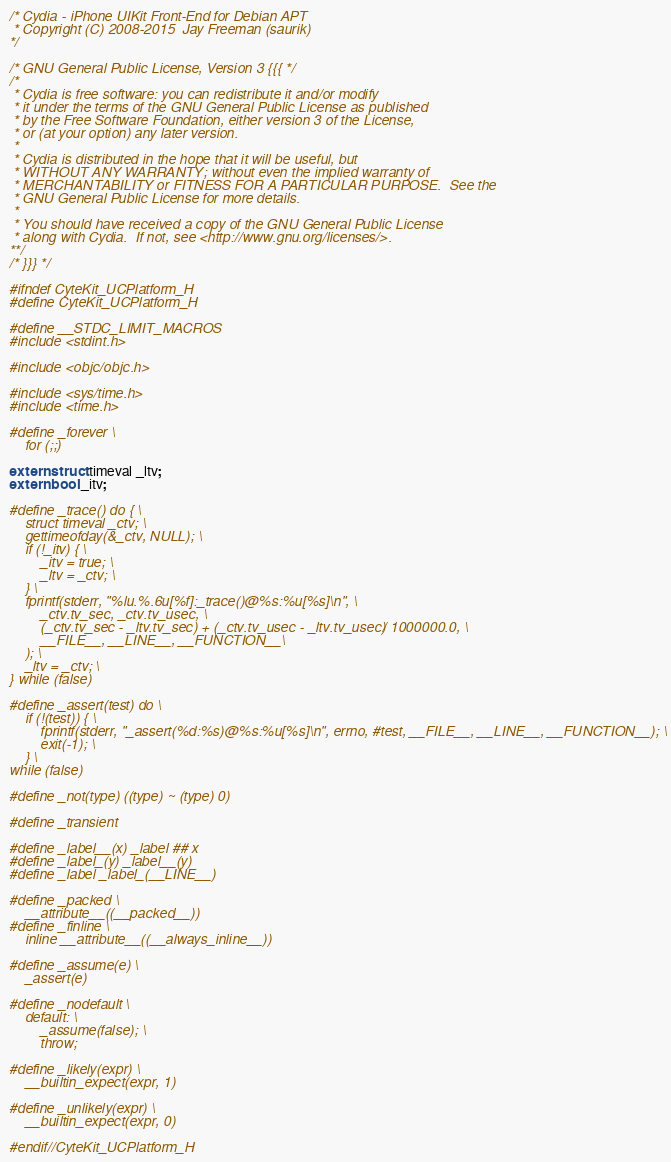<code> <loc_0><loc_0><loc_500><loc_500><_C_>/* Cydia - iPhone UIKit Front-End for Debian APT
 * Copyright (C) 2008-2015  Jay Freeman (saurik)
*/

/* GNU General Public License, Version 3 {{{ */
/*
 * Cydia is free software: you can redistribute it and/or modify
 * it under the terms of the GNU General Public License as published
 * by the Free Software Foundation, either version 3 of the License,
 * or (at your option) any later version.
 *
 * Cydia is distributed in the hope that it will be useful, but
 * WITHOUT ANY WARRANTY; without even the implied warranty of
 * MERCHANTABILITY or FITNESS FOR A PARTICULAR PURPOSE.  See the
 * GNU General Public License for more details.
 *
 * You should have received a copy of the GNU General Public License
 * along with Cydia.  If not, see <http://www.gnu.org/licenses/>.
**/
/* }}} */

#ifndef CyteKit_UCPlatform_H
#define CyteKit_UCPlatform_H

#define __STDC_LIMIT_MACROS
#include <stdint.h>

#include <objc/objc.h>

#include <sys/time.h>
#include <time.h>

#define _forever \
    for (;;)

extern struct timeval _ltv;
extern bool _itv;

#define _trace() do { \
    struct timeval _ctv; \
    gettimeofday(&_ctv, NULL); \
    if (!_itv) { \
        _itv = true; \
        _ltv = _ctv; \
    } \
    fprintf(stderr, "%lu.%.6u[%f]:_trace()@%s:%u[%s]\n", \
        _ctv.tv_sec, _ctv.tv_usec, \
        (_ctv.tv_sec - _ltv.tv_sec) + (_ctv.tv_usec - _ltv.tv_usec) / 1000000.0, \
        __FILE__, __LINE__, __FUNCTION__\
    ); \
    _ltv = _ctv; \
} while (false)

#define _assert(test) do \
    if (!(test)) { \
        fprintf(stderr, "_assert(%d:%s)@%s:%u[%s]\n", errno, #test, __FILE__, __LINE__, __FUNCTION__); \
        exit(-1); \
    } \
while (false)

#define _not(type) ((type) ~ (type) 0)

#define _transient

#define _label__(x) _label ## x
#define _label_(y) _label__(y)
#define _label _label_(__LINE__)

#define _packed \
    __attribute__((__packed__))
#define _finline \
    inline __attribute__((__always_inline__))

#define _assume(e) \
    _assert(e)

#define _nodefault \
    default: \
        _assume(false); \
        throw;

#define _likely(expr) \
    __builtin_expect(expr, 1)

#define _unlikely(expr) \
    __builtin_expect(expr, 0)

#endif//CyteKit_UCPlatform_H
</code> 